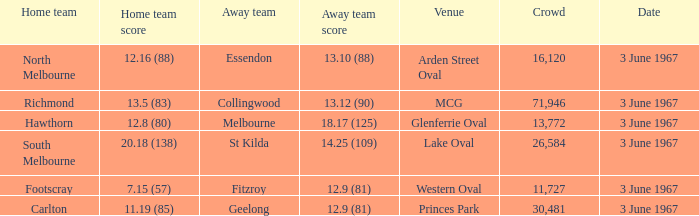Who was South Melbourne's away opponents? St Kilda. 